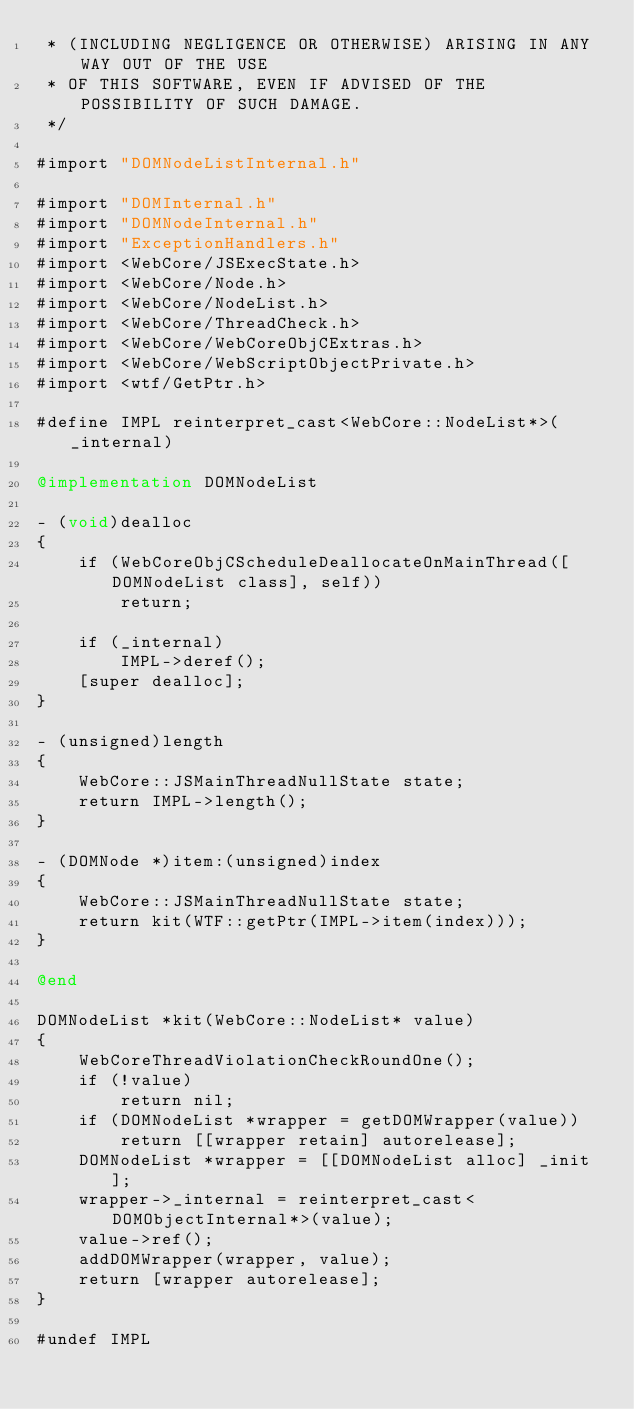Convert code to text. <code><loc_0><loc_0><loc_500><loc_500><_ObjectiveC_> * (INCLUDING NEGLIGENCE OR OTHERWISE) ARISING IN ANY WAY OUT OF THE USE
 * OF THIS SOFTWARE, EVEN IF ADVISED OF THE POSSIBILITY OF SUCH DAMAGE.
 */

#import "DOMNodeListInternal.h"

#import "DOMInternal.h"
#import "DOMNodeInternal.h"
#import "ExceptionHandlers.h"
#import <WebCore/JSExecState.h>
#import <WebCore/Node.h>
#import <WebCore/NodeList.h>
#import <WebCore/ThreadCheck.h>
#import <WebCore/WebCoreObjCExtras.h>
#import <WebCore/WebScriptObjectPrivate.h>
#import <wtf/GetPtr.h>

#define IMPL reinterpret_cast<WebCore::NodeList*>(_internal)

@implementation DOMNodeList

- (void)dealloc
{
    if (WebCoreObjCScheduleDeallocateOnMainThread([DOMNodeList class], self))
        return;

    if (_internal)
        IMPL->deref();
    [super dealloc];
}

- (unsigned)length
{
    WebCore::JSMainThreadNullState state;
    return IMPL->length();
}

- (DOMNode *)item:(unsigned)index
{
    WebCore::JSMainThreadNullState state;
    return kit(WTF::getPtr(IMPL->item(index)));
}

@end

DOMNodeList *kit(WebCore::NodeList* value)
{
    WebCoreThreadViolationCheckRoundOne();
    if (!value)
        return nil;
    if (DOMNodeList *wrapper = getDOMWrapper(value))
        return [[wrapper retain] autorelease];
    DOMNodeList *wrapper = [[DOMNodeList alloc] _init];
    wrapper->_internal = reinterpret_cast<DOMObjectInternal*>(value);
    value->ref();
    addDOMWrapper(wrapper, value);
    return [wrapper autorelease];
}

#undef IMPL
</code> 